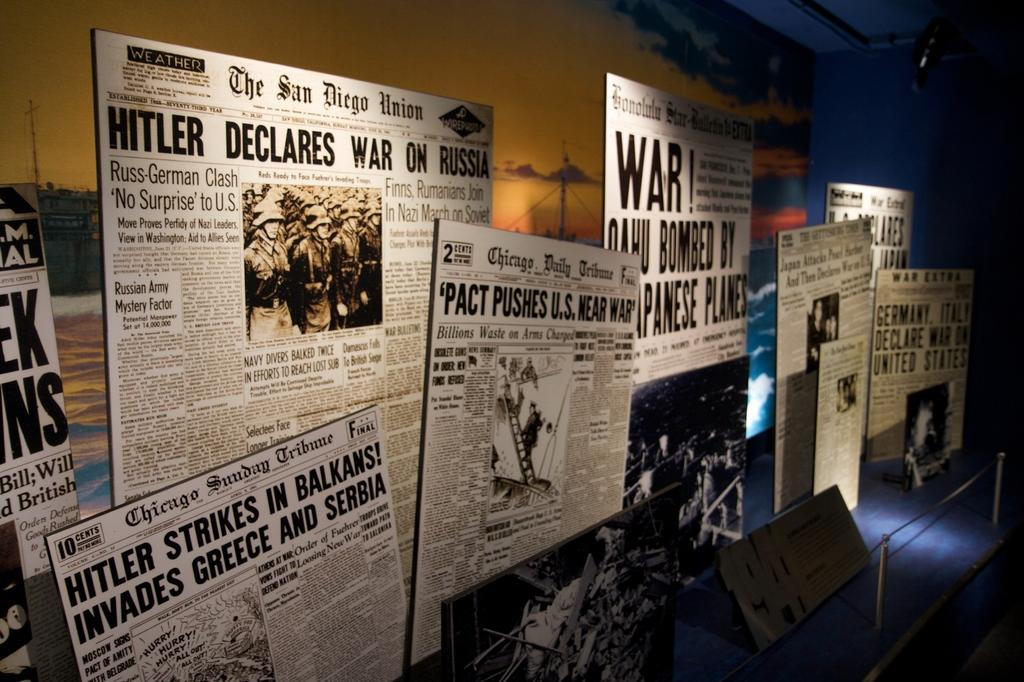<image>
Provide a brief description of the given image. Political newspapers that speak of the War and Hitler stand up in a museum. 